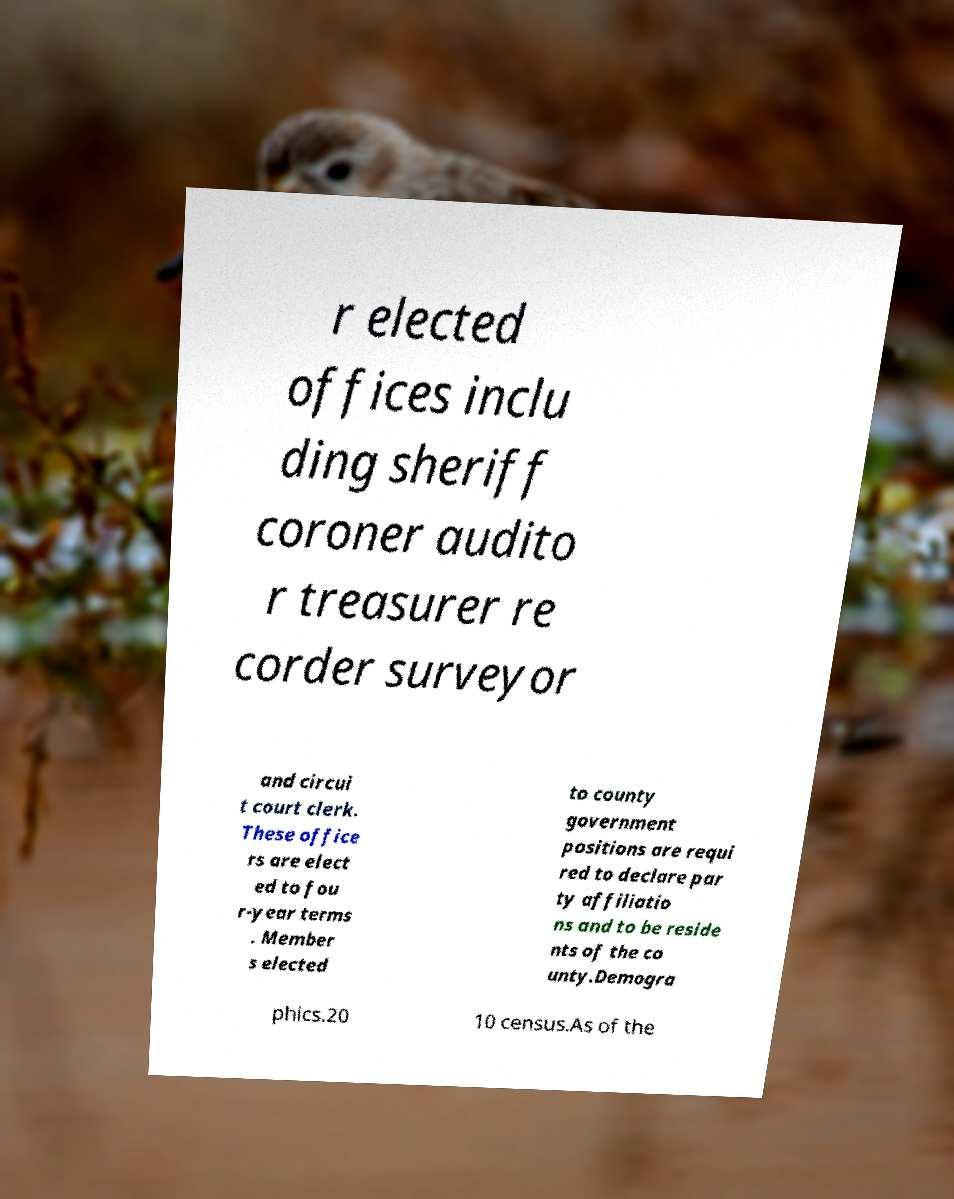Please identify and transcribe the text found in this image. r elected offices inclu ding sheriff coroner audito r treasurer re corder surveyor and circui t court clerk. These office rs are elect ed to fou r-year terms . Member s elected to county government positions are requi red to declare par ty affiliatio ns and to be reside nts of the co unty.Demogra phics.20 10 census.As of the 